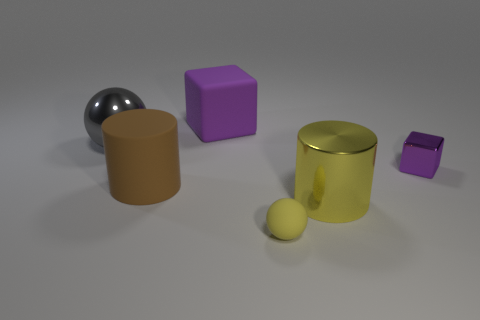Add 3 yellow rubber objects. How many objects exist? 9 Subtract all cylinders. How many objects are left? 4 Add 5 big brown cylinders. How many big brown cylinders are left? 6 Add 1 purple matte objects. How many purple matte objects exist? 2 Subtract 0 blue blocks. How many objects are left? 6 Subtract all tiny yellow rubber balls. Subtract all yellow metallic things. How many objects are left? 4 